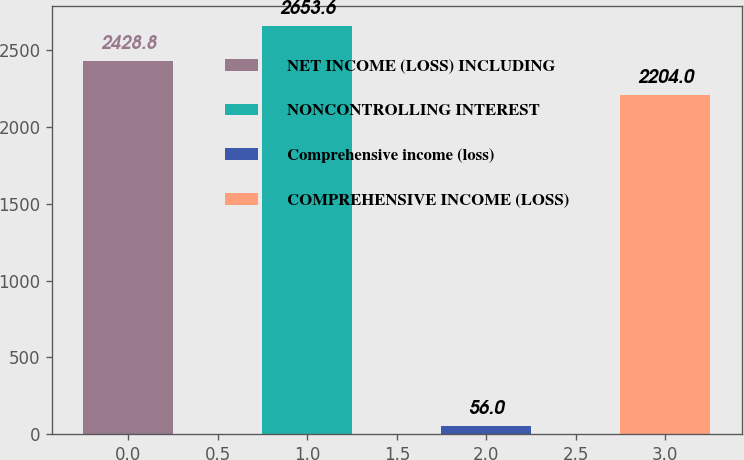Convert chart. <chart><loc_0><loc_0><loc_500><loc_500><bar_chart><fcel>NET INCOME (LOSS) INCLUDING<fcel>NONCONTROLLING INTEREST<fcel>Comprehensive income (loss)<fcel>COMPREHENSIVE INCOME (LOSS)<nl><fcel>2428.8<fcel>2653.6<fcel>56<fcel>2204<nl></chart> 